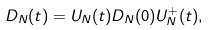<formula> <loc_0><loc_0><loc_500><loc_500>D _ { N } ( t ) = U _ { N } ( t ) D _ { N } ( 0 ) U _ { N } ^ { + } ( t ) ,</formula> 